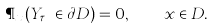<formula> <loc_0><loc_0><loc_500><loc_500>\P _ { x } ( Y _ { \tau _ { D } } \in \partial D ) = 0 , \quad x \in D .</formula> 